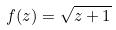Convert formula to latex. <formula><loc_0><loc_0><loc_500><loc_500>f ( z ) = \sqrt { z + 1 }</formula> 